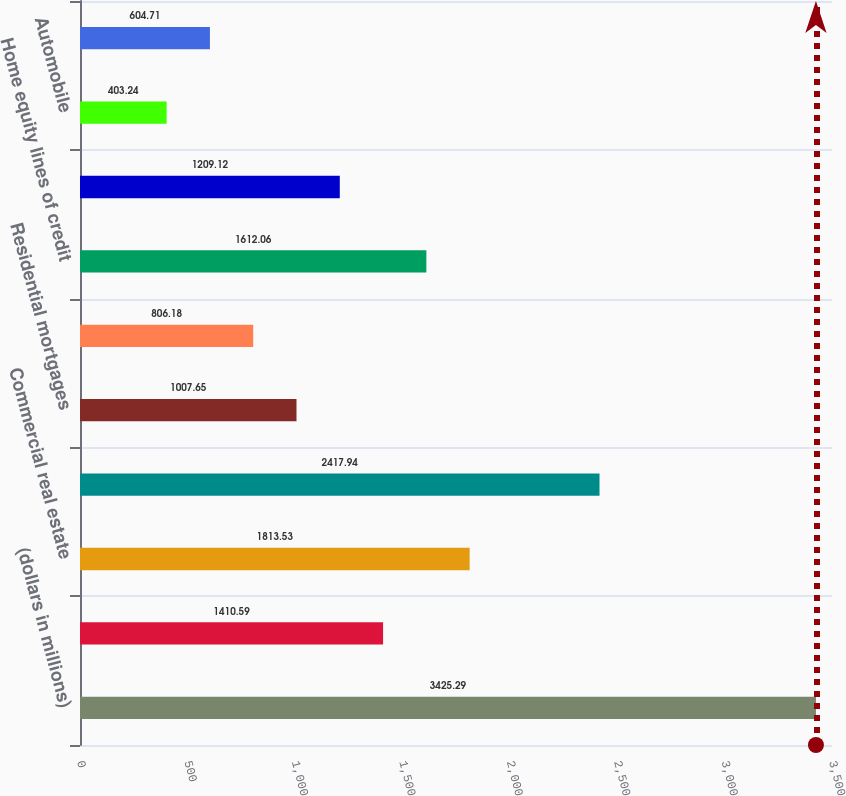<chart> <loc_0><loc_0><loc_500><loc_500><bar_chart><fcel>(dollars in millions)<fcel>Commercial<fcel>Commercial real estate<fcel>Total commercial<fcel>Residential mortgages<fcel>Home equity loans<fcel>Home equity lines of credit<fcel>Home equity loans serviced by<fcel>Automobile<fcel>Credit cards<nl><fcel>3425.29<fcel>1410.59<fcel>1813.53<fcel>2417.94<fcel>1007.65<fcel>806.18<fcel>1612.06<fcel>1209.12<fcel>403.24<fcel>604.71<nl></chart> 